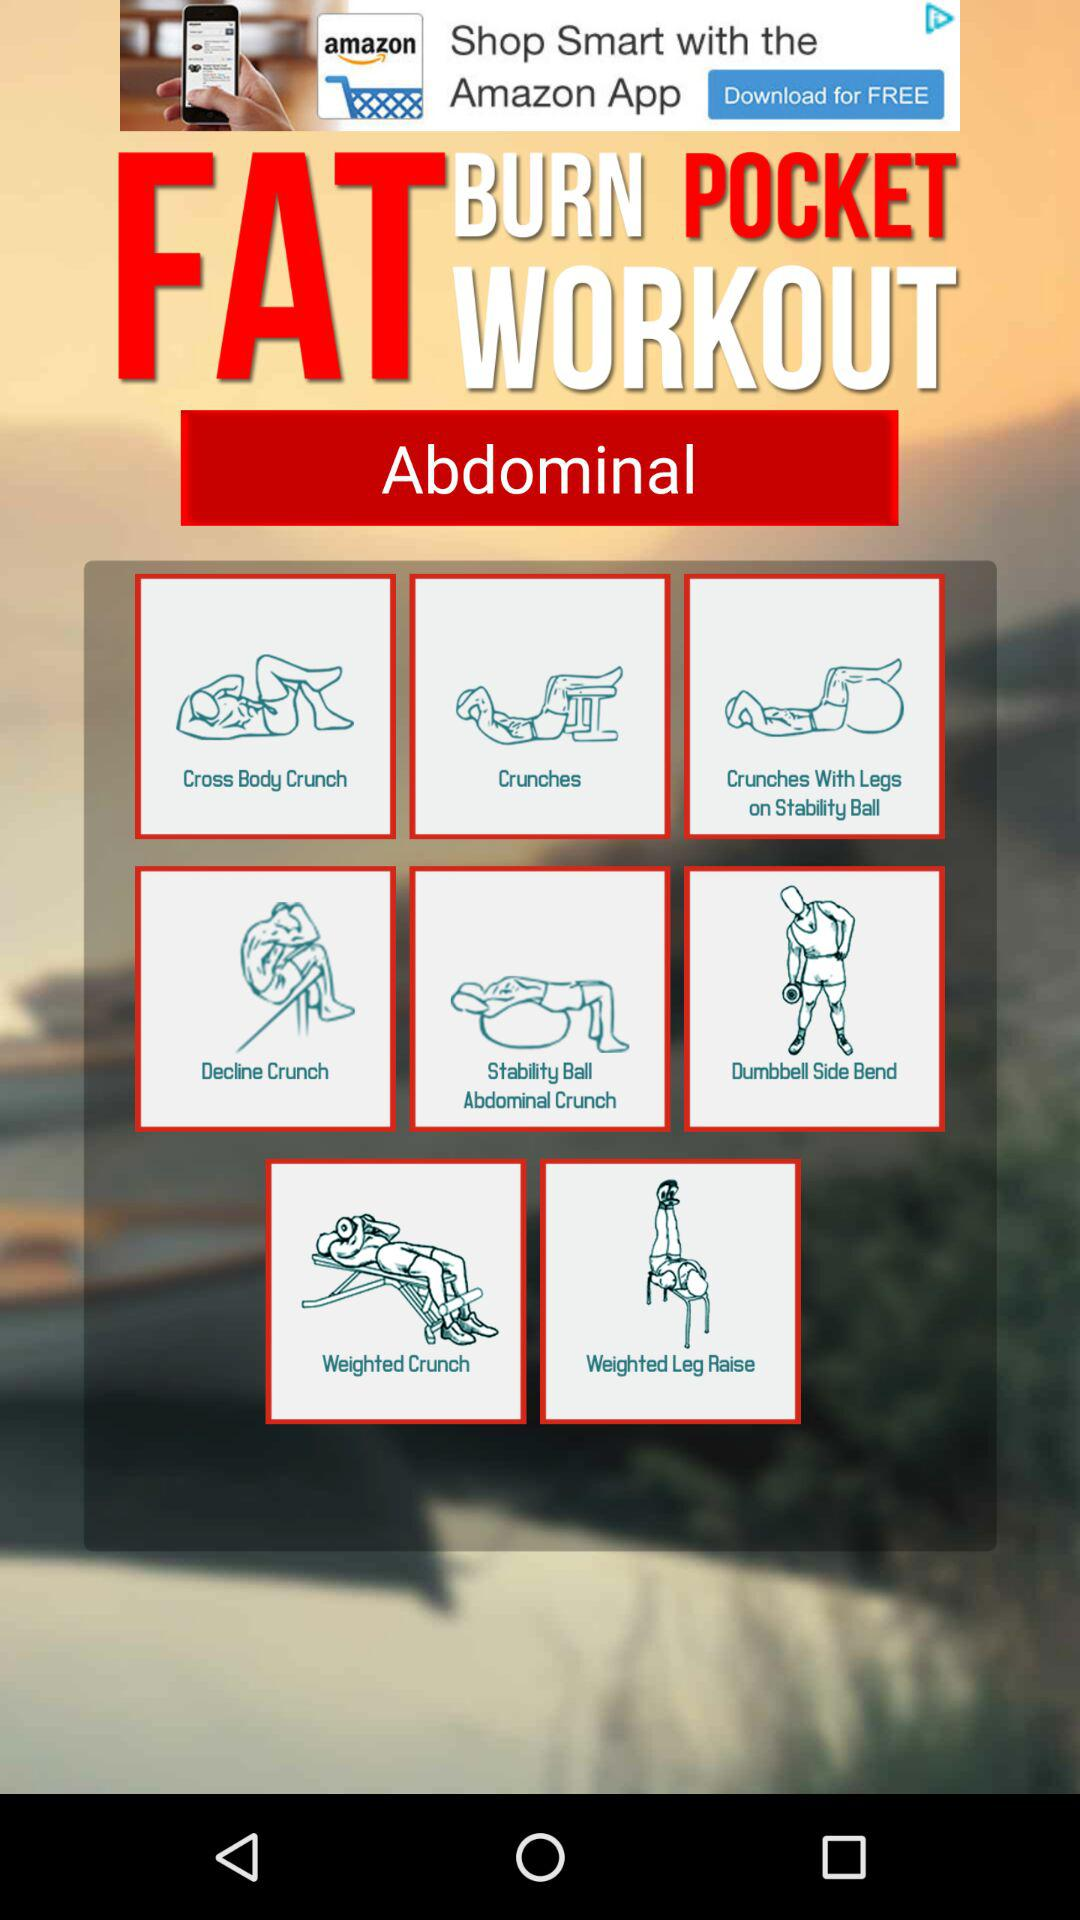What are the names of the given exercises? The names of the given exercises are "Cross Body Crunch", "Crunches", "Crunches With Legs on Stability Ball", "Decline Crunch", "Stability Ball Abdominal Crunch", "Dumbbell Side Bend", "Weighted Crunch" and "Weighted Leg Raise". 